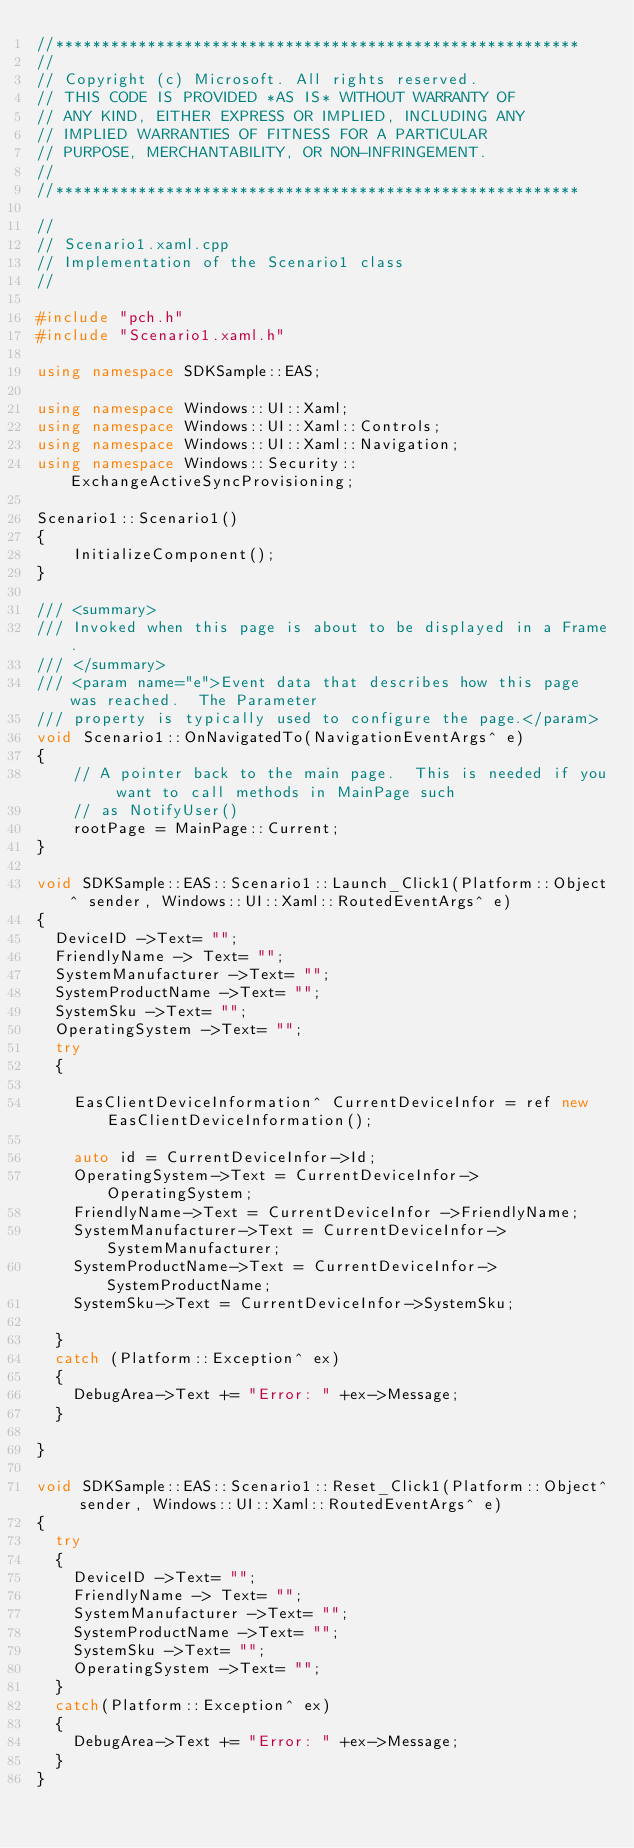Convert code to text. <code><loc_0><loc_0><loc_500><loc_500><_C++_>//*********************************************************
//
// Copyright (c) Microsoft. All rights reserved.
// THIS CODE IS PROVIDED *AS IS* WITHOUT WARRANTY OF
// ANY KIND, EITHER EXPRESS OR IMPLIED, INCLUDING ANY
// IMPLIED WARRANTIES OF FITNESS FOR A PARTICULAR
// PURPOSE, MERCHANTABILITY, OR NON-INFRINGEMENT.
//
//*********************************************************

//
// Scenario1.xaml.cpp
// Implementation of the Scenario1 class
//

#include "pch.h"
#include "Scenario1.xaml.h"

using namespace SDKSample::EAS;

using namespace Windows::UI::Xaml;
using namespace Windows::UI::Xaml::Controls;
using namespace Windows::UI::Xaml::Navigation;
using namespace Windows::Security::ExchangeActiveSyncProvisioning;

Scenario1::Scenario1()
{
    InitializeComponent();
}

/// <summary>
/// Invoked when this page is about to be displayed in a Frame.
/// </summary>
/// <param name="e">Event data that describes how this page was reached.  The Parameter
/// property is typically used to configure the page.</param>
void Scenario1::OnNavigatedTo(NavigationEventArgs^ e)
{
    // A pointer back to the main page.  This is needed if you want to call methods in MainPage such
    // as NotifyUser()
    rootPage = MainPage::Current;
}

void SDKSample::EAS::Scenario1::Launch_Click1(Platform::Object^ sender, Windows::UI::Xaml::RoutedEventArgs^ e)
{
	DeviceID ->Text= "";	
	FriendlyName -> Text= "";
	SystemManufacturer ->Text= "";
	SystemProductName ->Text= "";
	SystemSku ->Text= "";
	OperatingSystem ->Text= "";
	try
	{

		EasClientDeviceInformation^ CurrentDeviceInfor = ref new EasClientDeviceInformation();
		
		auto id = CurrentDeviceInfor->Id;
		OperatingSystem->Text = CurrentDeviceInfor->OperatingSystem;
		FriendlyName->Text = CurrentDeviceInfor ->FriendlyName;
		SystemManufacturer->Text = CurrentDeviceInfor->SystemManufacturer;
		SystemProductName->Text = CurrentDeviceInfor->SystemProductName;
		SystemSku->Text = CurrentDeviceInfor->SystemSku;

	} 
	catch (Platform::Exception^ ex)
	{
		DebugArea->Text += "Error: " +ex->Message;
	}
    
}

void SDKSample::EAS::Scenario1::Reset_Click1(Platform::Object^ sender, Windows::UI::Xaml::RoutedEventArgs^ e)
{
	try
	{
		DeviceID ->Text= "";	
		FriendlyName -> Text= "";
		SystemManufacturer ->Text= "";
		SystemProductName ->Text= "";
		SystemSku ->Text= "";
		OperatingSystem ->Text= "";
	}
	catch(Platform::Exception^ ex)
	{
		DebugArea->Text += "Error: " +ex->Message;
	}
}
</code> 